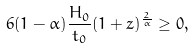Convert formula to latex. <formula><loc_0><loc_0><loc_500><loc_500>6 ( 1 - \alpha ) \frac { H _ { 0 } } { t _ { 0 } } ( 1 + z ) ^ { \frac { 2 } { \alpha } } \geq 0 ,</formula> 